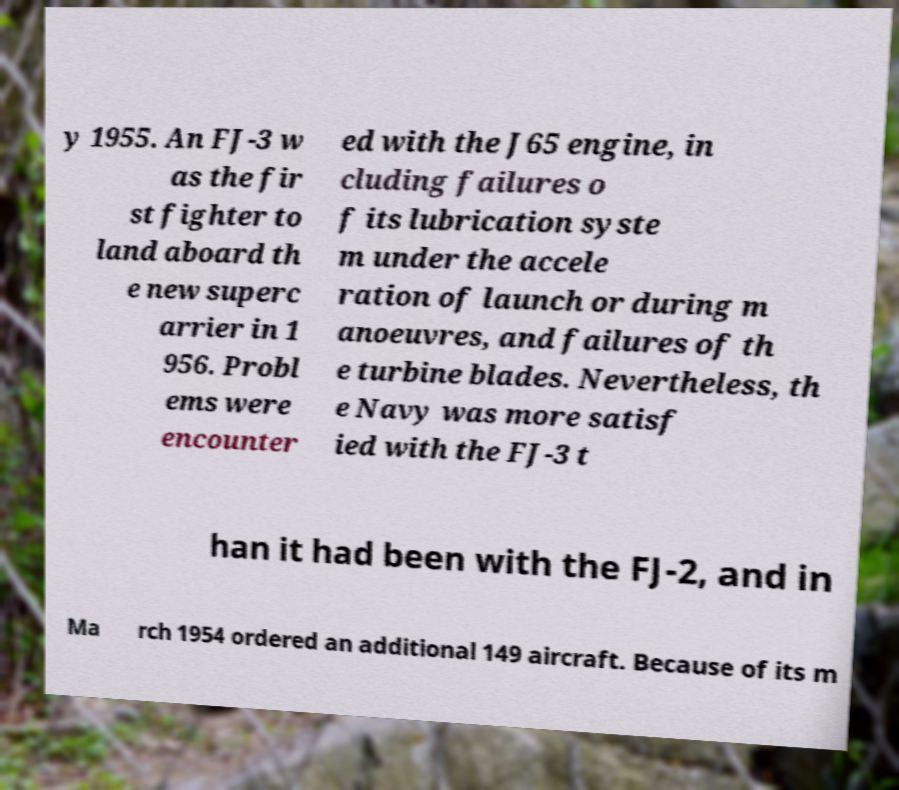Can you accurately transcribe the text from the provided image for me? y 1955. An FJ-3 w as the fir st fighter to land aboard th e new superc arrier in 1 956. Probl ems were encounter ed with the J65 engine, in cluding failures o f its lubrication syste m under the accele ration of launch or during m anoeuvres, and failures of th e turbine blades. Nevertheless, th e Navy was more satisf ied with the FJ-3 t han it had been with the FJ-2, and in Ma rch 1954 ordered an additional 149 aircraft. Because of its m 